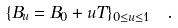Convert formula to latex. <formula><loc_0><loc_0><loc_500><loc_500>\{ B _ { u } = B _ { 0 } + u T \} _ { 0 \leq u \leq 1 } \ \, .</formula> 